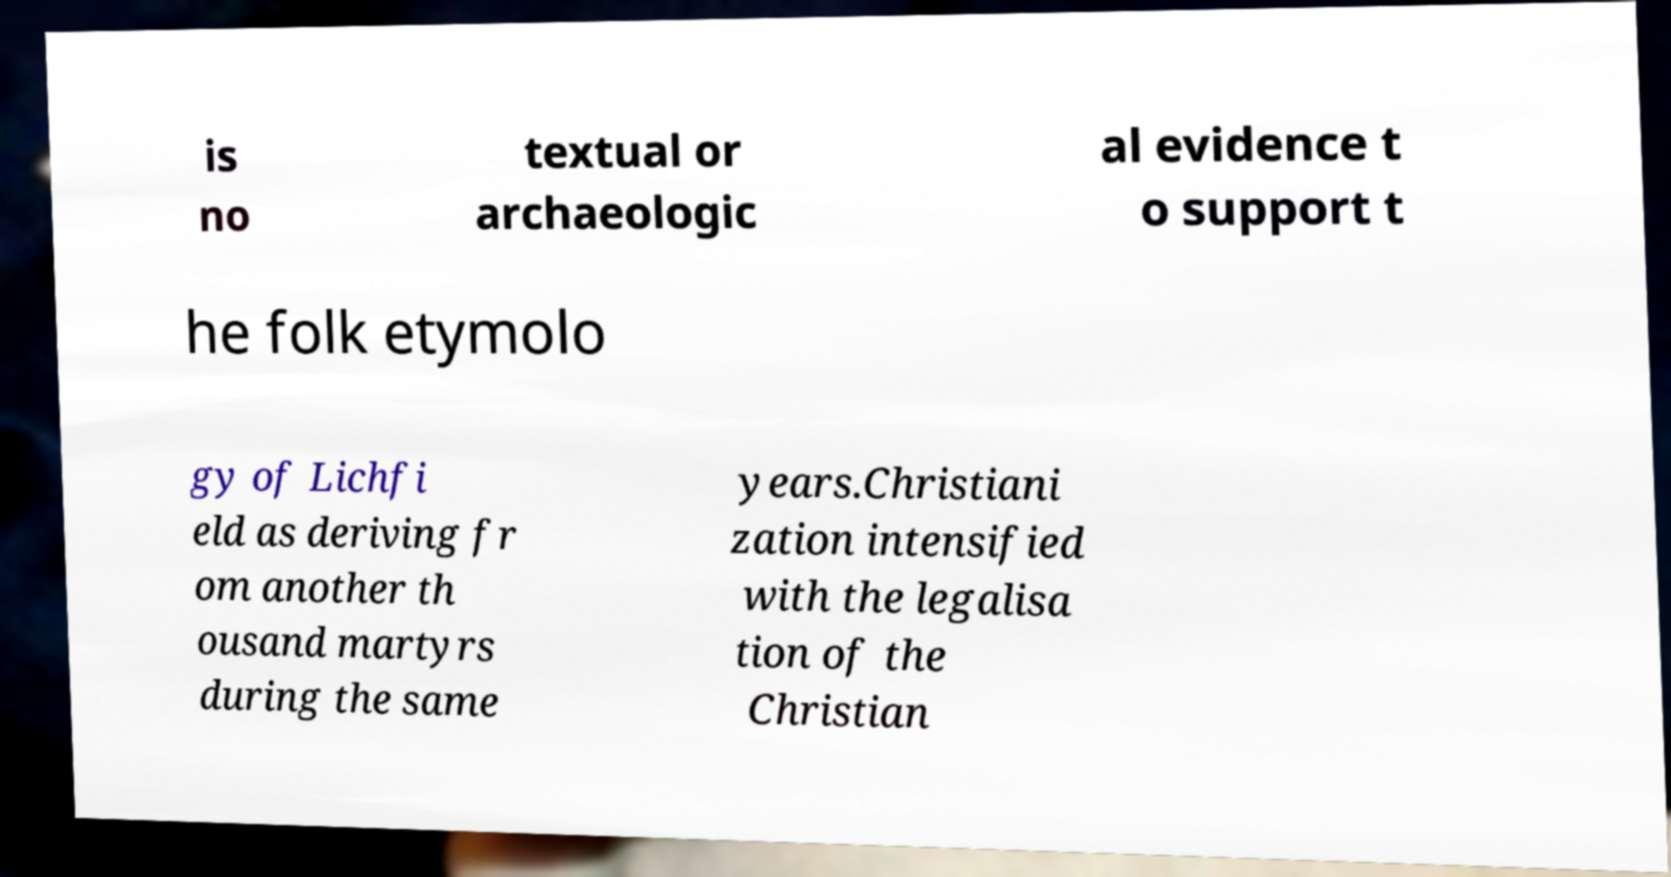Can you read and provide the text displayed in the image?This photo seems to have some interesting text. Can you extract and type it out for me? is no textual or archaeologic al evidence t o support t he folk etymolo gy of Lichfi eld as deriving fr om another th ousand martyrs during the same years.Christiani zation intensified with the legalisa tion of the Christian 